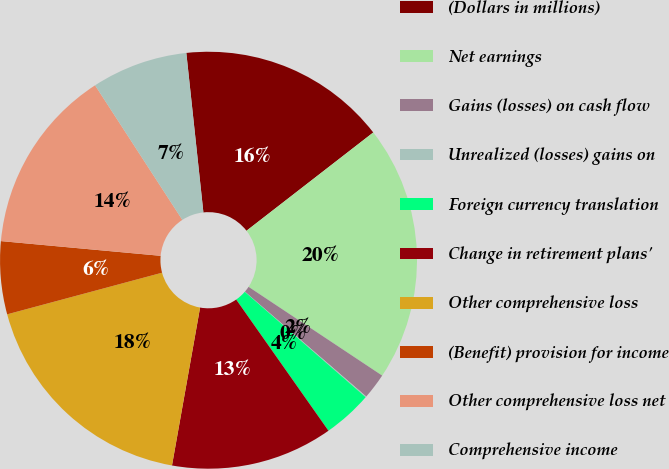<chart> <loc_0><loc_0><loc_500><loc_500><pie_chart><fcel>(Dollars in millions)<fcel>Net earnings<fcel>Gains (losses) on cash flow<fcel>Unrealized (losses) gains on<fcel>Foreign currency translation<fcel>Change in retirement plans'<fcel>Other comprehensive loss<fcel>(Benefit) provision for income<fcel>Other comprehensive loss net<fcel>Comprehensive income<nl><fcel>16.2%<fcel>19.83%<fcel>2.01%<fcel>0.07%<fcel>3.83%<fcel>12.56%<fcel>18.02%<fcel>5.64%<fcel>14.38%<fcel>7.46%<nl></chart> 